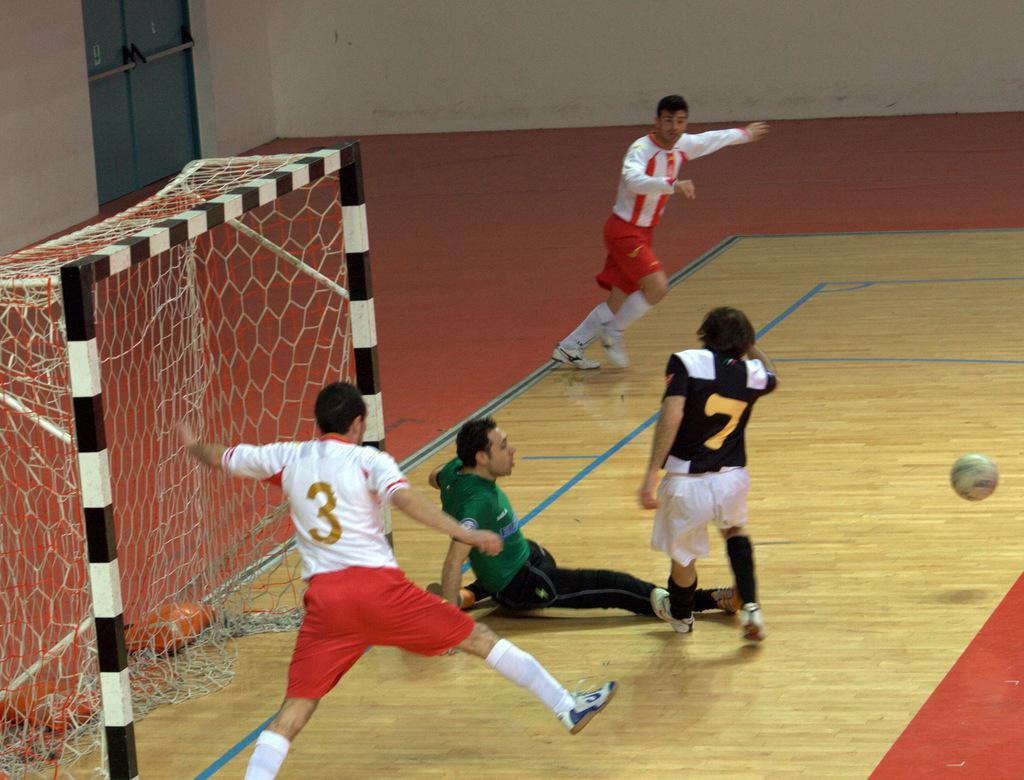Please provide a concise description of this image. In this picture I can see three men are standing and one man is sitting. Here I can see a net and a ball in the air. On the floor I can see some blue color lines. In the background I can see a wall and a door. These people are wearing jerseys, shorts and shoes. 